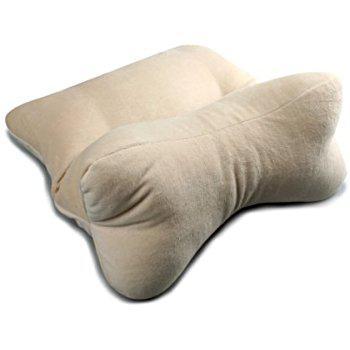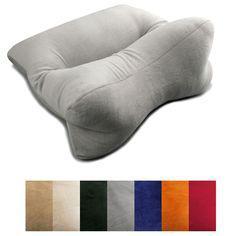The first image is the image on the left, the second image is the image on the right. For the images displayed, is the sentence "In one image, a woman with dark hair rests her head on a pillow" factually correct? Answer yes or no. No. The first image is the image on the left, the second image is the image on the right. Examine the images to the left and right. Is the description "A brunette woman is sleeping on a pillow" accurate? Answer yes or no. No. 